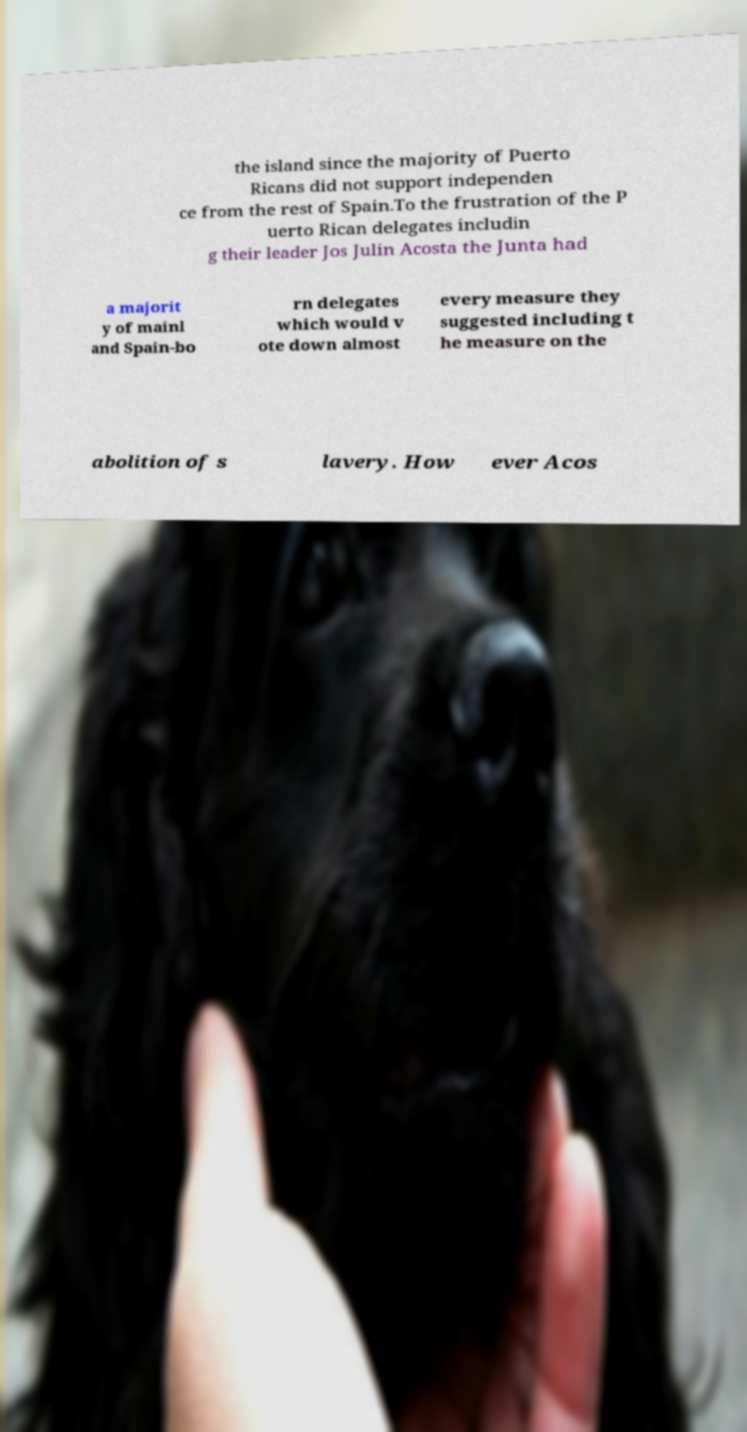Could you assist in decoding the text presented in this image and type it out clearly? the island since the majority of Puerto Ricans did not support independen ce from the rest of Spain.To the frustration of the P uerto Rican delegates includin g their leader Jos Julin Acosta the Junta had a majorit y of mainl and Spain-bo rn delegates which would v ote down almost every measure they suggested including t he measure on the abolition of s lavery. How ever Acos 